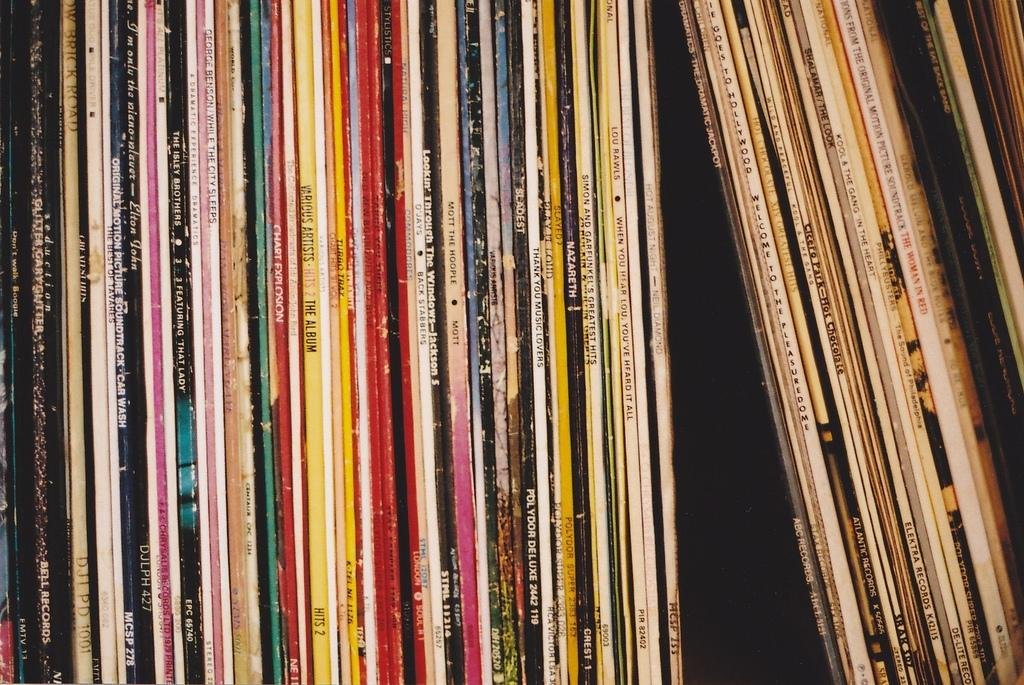<image>
Describe the image concisely. Record albums are lined up including music from The Isley Brothers and Neil Diamond. 